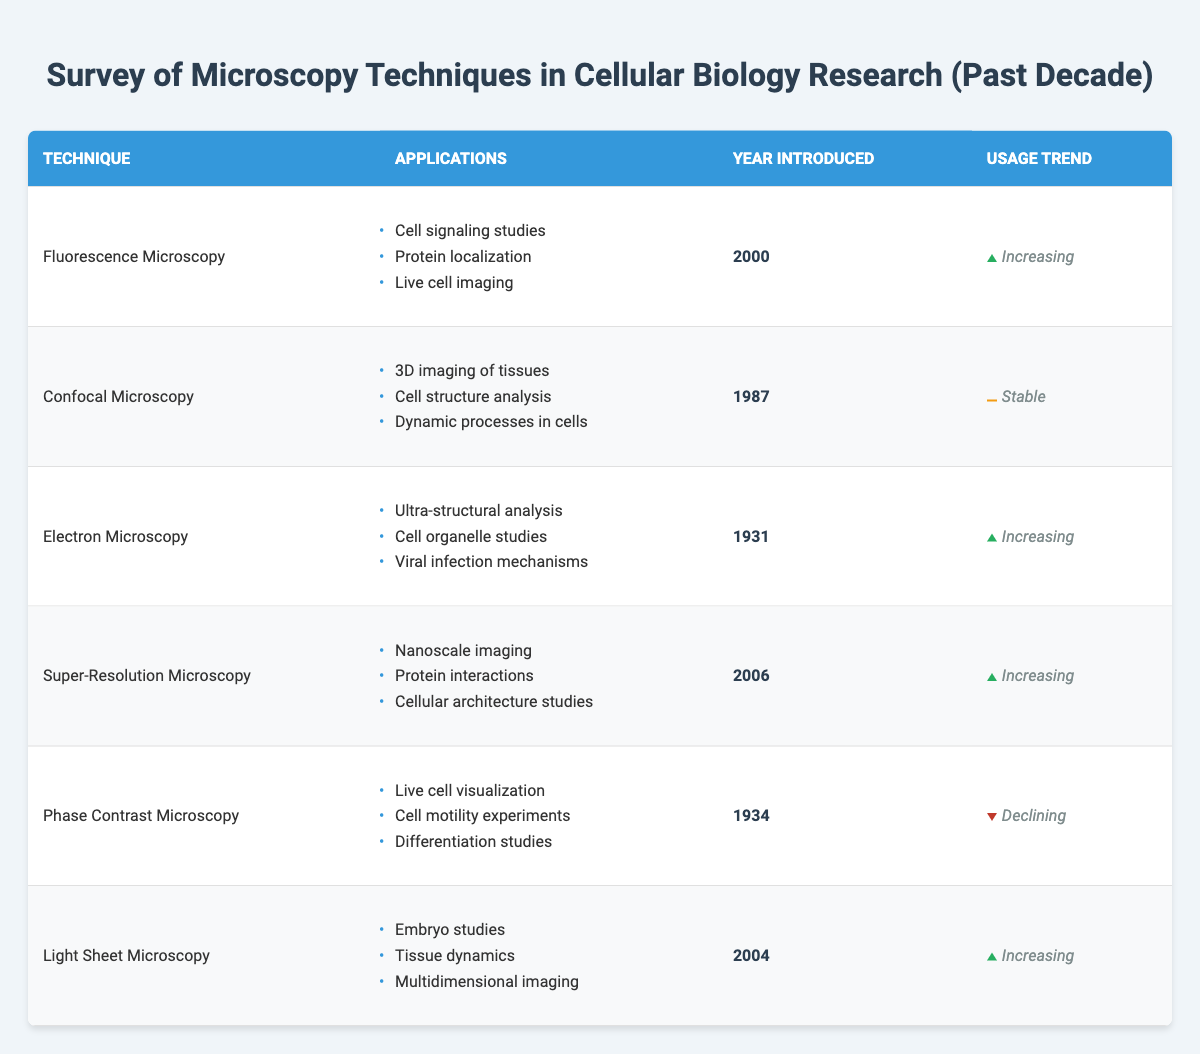What is the year when Super-Resolution Microscopy was introduced? The table lists Super-Resolution Microscopy under the column "Year Introduced," which shows 2006 for this technique.
Answer: 2006 Which microscopy technique has a declining usage trend? According to the table, Phase Contrast Microscopy is the only technique marked as having a "Declining" usage trend.
Answer: Phase Contrast Microscopy How many techniques introduced after the year 2000 are currently increasing in usage? The techniques introduced after 2000 are Fluorescence Microscopy (2000), Super-Resolution Microscopy (2006), and Light Sheet Microscopy (2004). Among these, all three are listed with an "Increasing" usage trend, resulting in a total of three techniques.
Answer: 3 Are there any microscopy techniques used for live cell imaging according to the table? Yes, the table shows that both Fluorescence Microscopy and Phase Contrast Microscopy are used for live cell imaging as indicated in their applications.
Answer: Yes What is the usage trend of Electron Microscopy, and when was it introduced? The table indicates that Electron Microscopy was introduced in 1931 and has an "Increasing" usage trend, making it a longer-established technique with rising usage.
Answer: Increasing, 1931 What is the total number of microscopy techniques listed in the table? The table contains a total of six techniques: Fluorescence Microscopy, Confocal Microscopy, Electron Microscopy, Super-Resolution Microscopy, Phase Contrast Microscopy, and Light Sheet Microscopy. Therefore, the total count is six.
Answer: 6 Which microscopy technique is mainly used for 3D imaging of tissues? The table states that Confocal Microscopy application includes "3D imaging of tissues," which identifies it as the technique used for this purpose.
Answer: Confocal Microscopy Which microscopy technique has applications related to viral infection mechanisms? The table indicates that Electron Microscopy has applications listed for studying "Viral infection mechanisms," highlighting its relevance to this area of research.
Answer: Electron Microscopy How many techniques are primarily aimed at cellular architecture studies? Based on the table, only Super-Resolution Microscopy focuses on "Cellular architecture studies," so the count is one technique specifically aimed at this application.
Answer: 1 